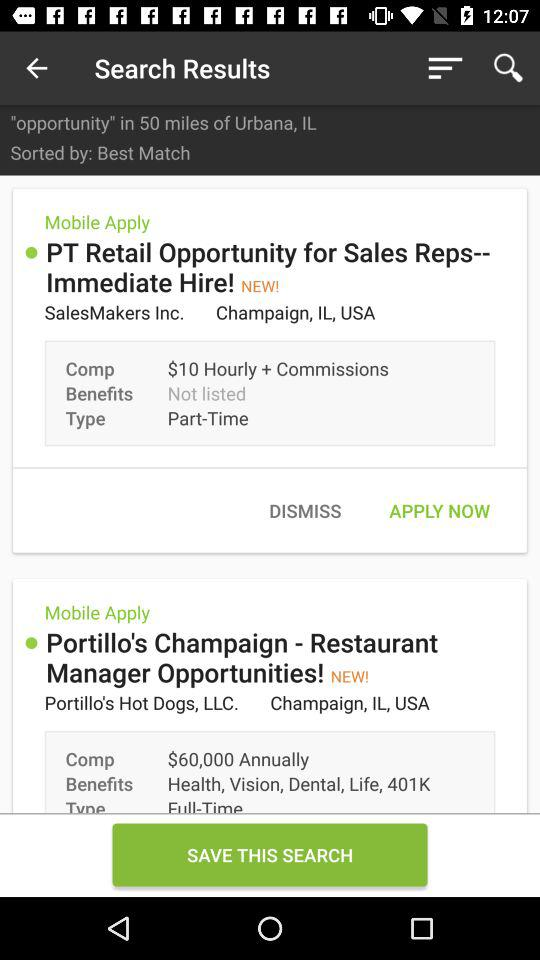What kind of job opportunity is available in "PT Retail"? Job opportunities for "Sales Reps" are available in "PT Retail". 